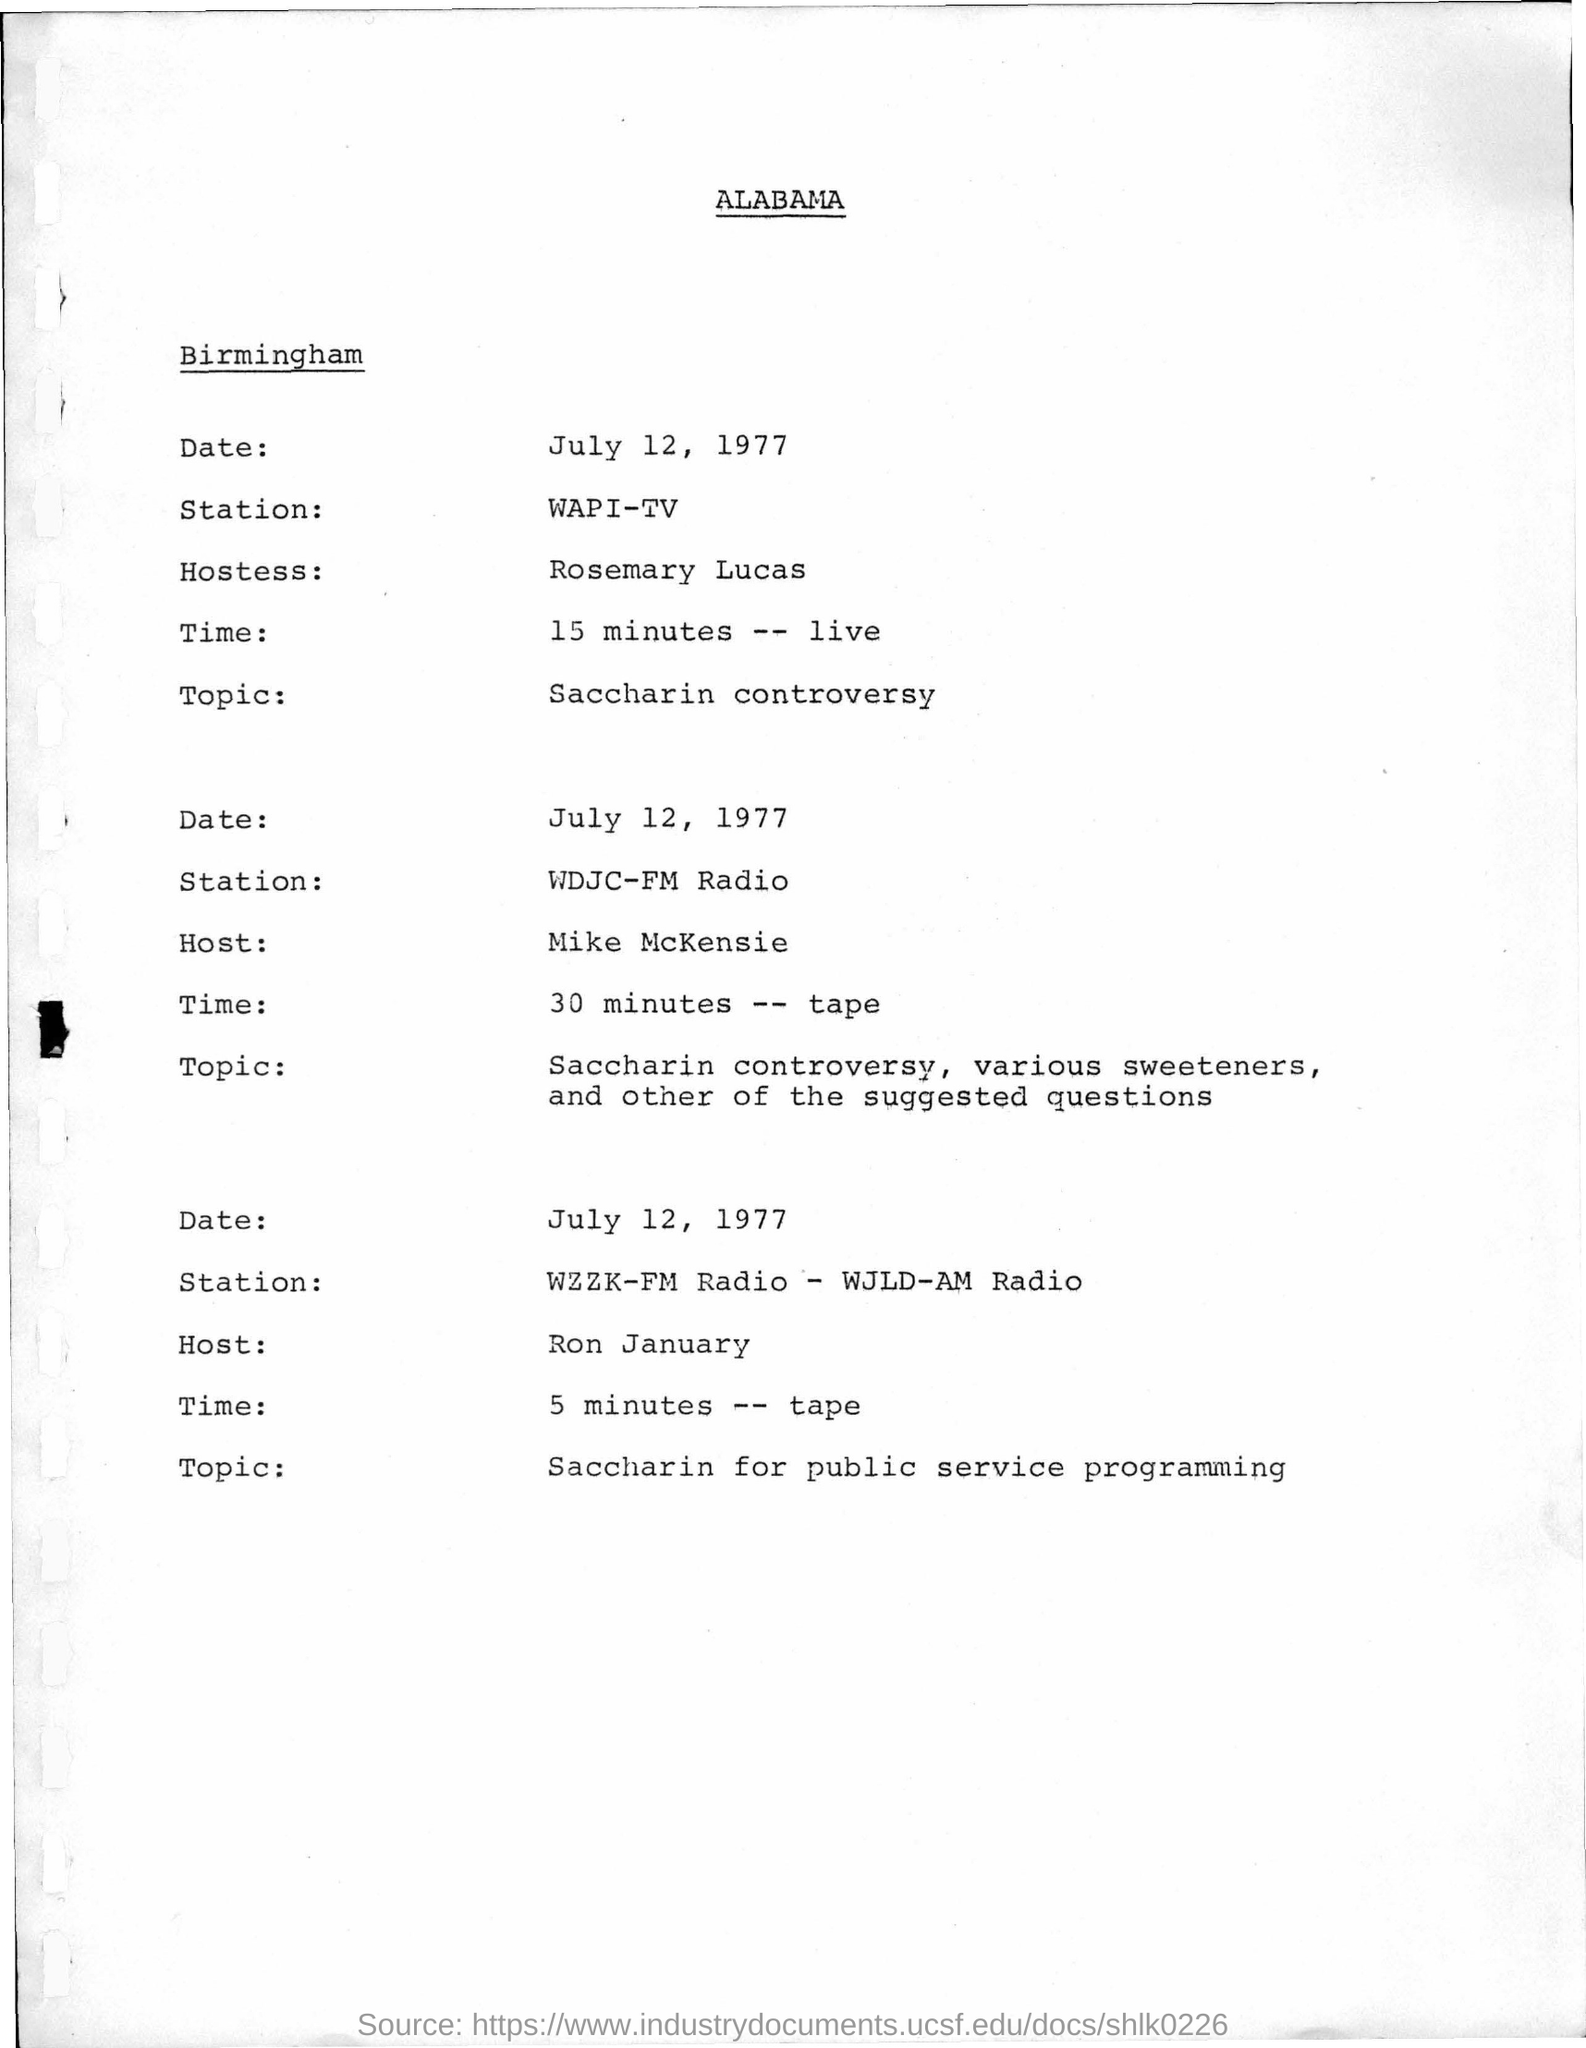Outline some significant characteristics in this image. Rosemary Lucas is the hostess for the live program at WAPI-TV. The speaker announces that Ron January is the host for the Saccharin for Public Service Programming. 